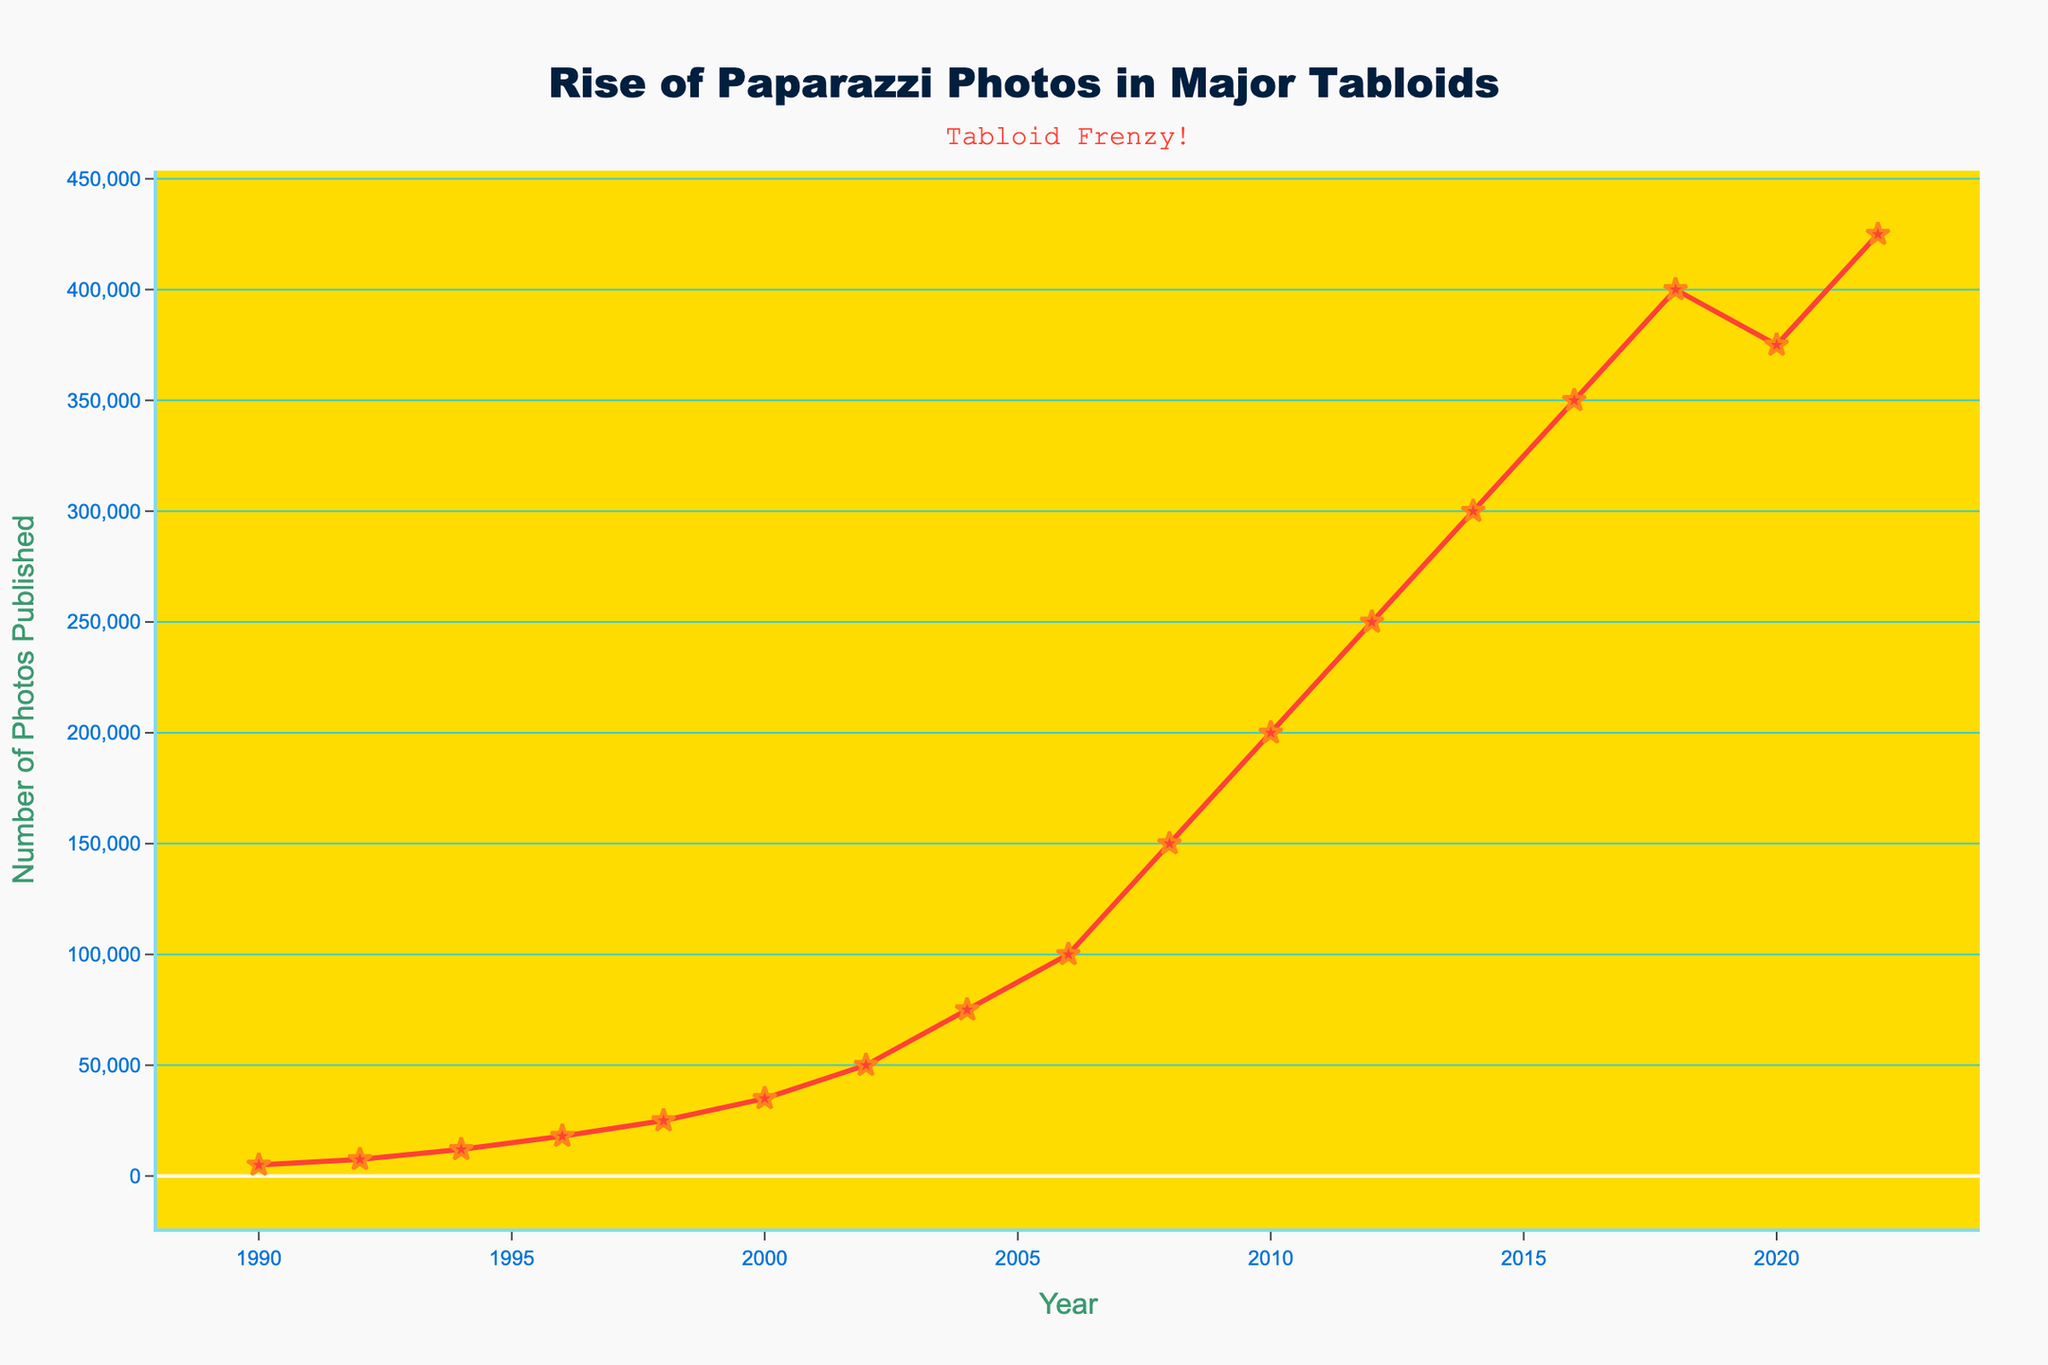How does the number of paparazzi photos published in 2000 compare to 1990? Compare the values for the years 2000 and 1990. In 2000, the number of photos published was 35,000, while in 1990, it was 5,000. Since 35,000 is greater than 5,000, the number increased.
Answer: Increased What is the difference in the number of paparazzi photos published between the highest and the lowest years in the dataset? The highest value is in 2022, with 425,000 photos published, and the lowest is in 1990, with 5,000 photos published. Subtracting these values gives 425,000 - 5,000 = 420,000.
Answer: 420,000 In which year did the number of paparazzi photos published reach 100,000 for the first time? Look for the first year where the value reaches or exceeds 100,000. In 2006, the number of photos published was 100,000.
Answer: 2006 By how much did the number of paparazzi photos published increase from 2018 to 2020? The values for 2018 and 2020 are 400,000 and 375,000 respectively. Calculate the difference: 400,000 - 375,000 = 25,000. Since the value decreases, the increase is actually -25,000.
Answer: -25,000 Which year saw the highest year-over-year increase in the number of paparazzi photos published? Calculate the difference for each two-year period and compare. The highest year-over-year increase was between 2006 (100,000) and 2008 (150,000), giving an increase of 50,000 photos.
Answer: 2008 From 1990 to 1998, by how many times did the number of paparazzi photos published increase? In 1990, the value was 5,000, and in 1998, it was 25,000. Divide 25,000 by 5,000 to find the multiplier: 25,000 / 5,000 = 5 times.
Answer: 5 times What is the average number of paparazzi photos published per year over the period 1990 to 2022? Sum all the annual values and divide by the number of years (17). (5000 + 7500 + 12000 + 18000 + 25000 + 35000 + 50000 + 75000 + 100000 + 150000 + 200000 + 250000 + 300000 + 350000 + 400000 + 375000 + 425000) / 17 = 157,353 photos.
Answer: 157,353 Was there any year when the number of paparazzi photos published decreased compared to the previous year? Check the dataset for decreases compared to the previous year. The years 2020 (375,000) decreased from 2018 (400,000), showing a reduction.
Answer: 2020 In what year did the number of paparazzi photos published exceed 150,000 for the first time? Look for the first year where the number exceeds 150,000. In 2008, the number was 150,000, indicating the first year it reached this value.
Answer: 2008 